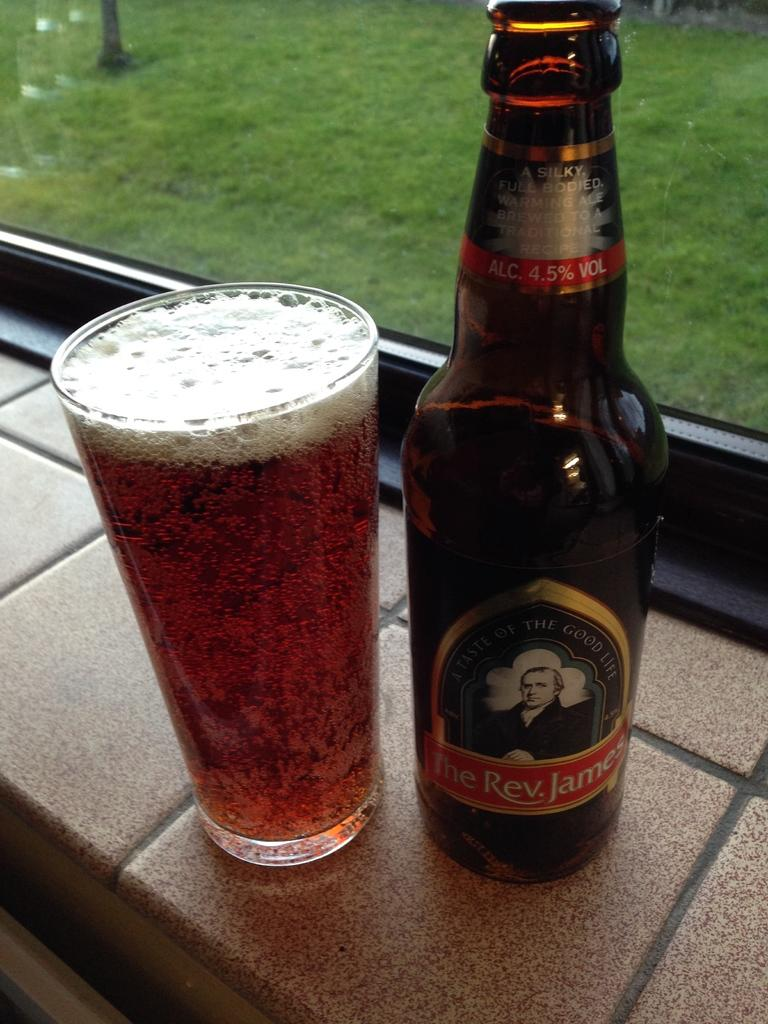<image>
Present a compact description of the photo's key features. A bottle of The Rev. James beer has been poured into a glass. 